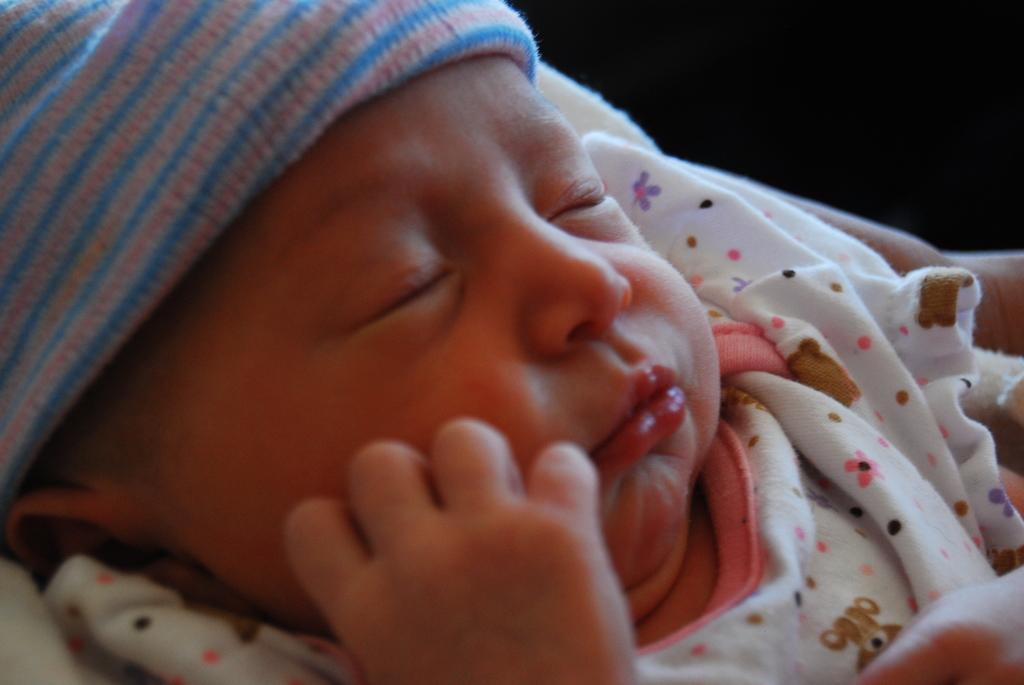Can you describe this image briefly? In this picture I can see there is an infant sleeping and there is a blanket on her and there is a dark backdrop. 